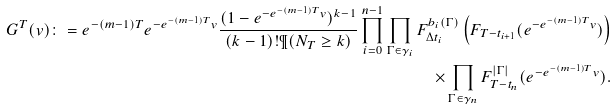<formula> <loc_0><loc_0><loc_500><loc_500>G ^ { T } ( v ) \colon = e ^ { - ( m - 1 ) T } e ^ { - e ^ { - ( m - 1 ) T } v } \frac { ( 1 - e ^ { - e ^ { - ( m - 1 ) T } v } ) ^ { k - 1 } } { ( k - 1 ) ! \P ( N _ { T } \geq k ) } \prod _ { i = 0 } ^ { n - 1 } \prod _ { \Gamma \in \gamma _ { i } } F _ { \Delta t _ { i } } ^ { b _ { i } ( \Gamma ) } \left ( F _ { T - t _ { i + 1 } } ( e ^ { - e ^ { - ( m - 1 ) T } v } ) \right ) \\ \times \prod _ { \Gamma \in \gamma _ { n } } F _ { T - t _ { n } } ^ { | \Gamma | } ( e ^ { - e ^ { - ( m - 1 ) T } v } ) .</formula> 